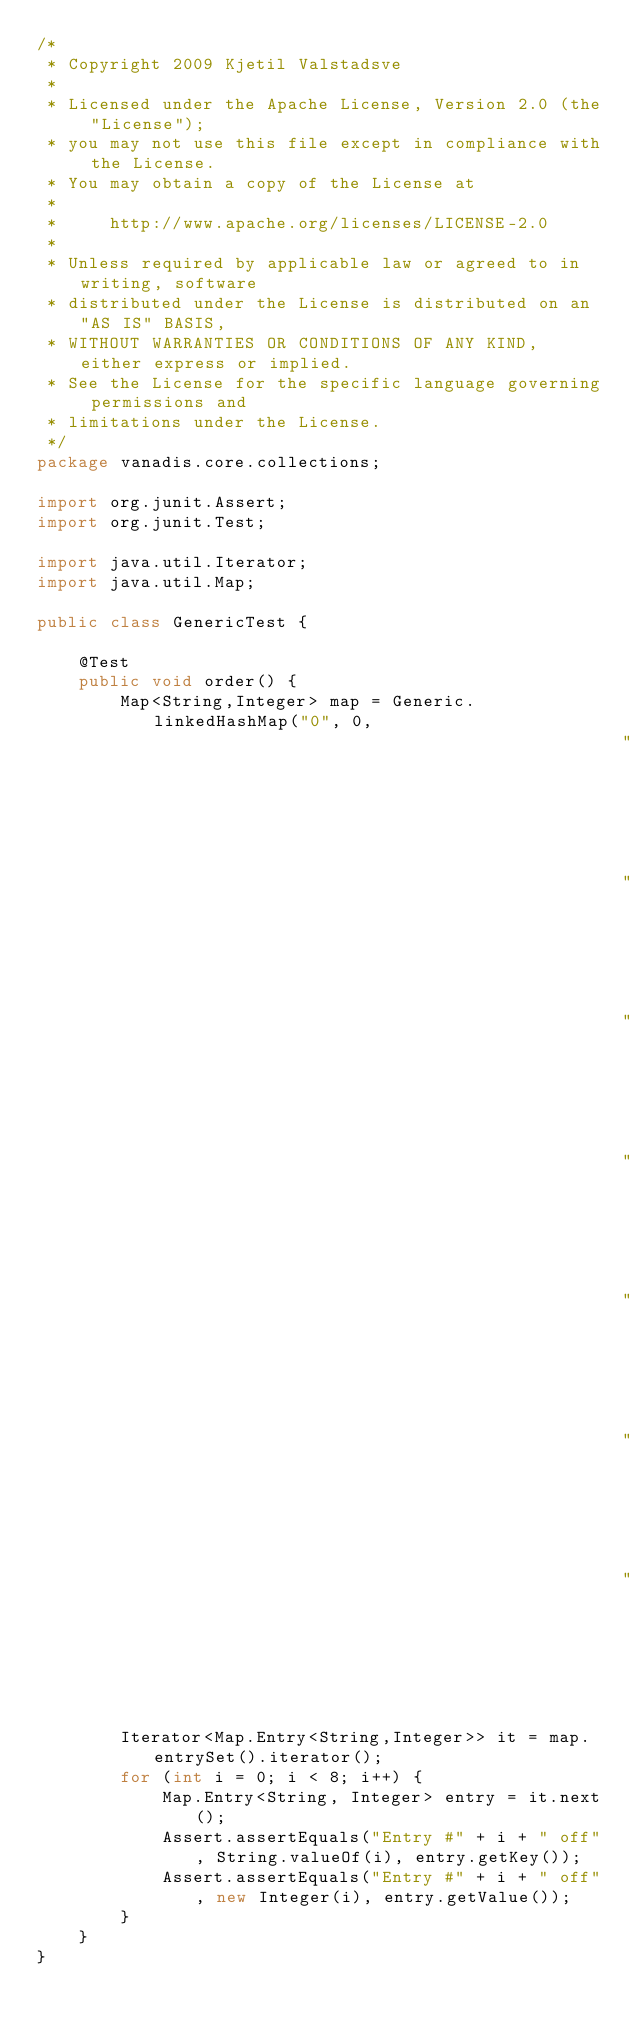Convert code to text. <code><loc_0><loc_0><loc_500><loc_500><_Java_>/*
 * Copyright 2009 Kjetil Valstadsve
 *
 * Licensed under the Apache License, Version 2.0 (the "License");
 * you may not use this file except in compliance with the License.
 * You may obtain a copy of the License at
 *
 *     http://www.apache.org/licenses/LICENSE-2.0
 *
 * Unless required by applicable law or agreed to in writing, software
 * distributed under the License is distributed on an "AS IS" BASIS,
 * WITHOUT WARRANTIES OR CONDITIONS OF ANY KIND, either express or implied.
 * See the License for the specific language governing permissions and
 * limitations under the License.
 */
package vanadis.core.collections;

import org.junit.Assert;
import org.junit.Test;

import java.util.Iterator;
import java.util.Map;

public class GenericTest {

    @Test
    public void order() {
        Map<String,Integer> map = Generic.linkedHashMap("0", 0,
                                                        "1", 1,
                                                        "2", 2,
                                                        "3", 3,
                                                        "4", 4,
                                                        "5", 5,
                                                        "6", 6,
                                                        "7", 7);
        Iterator<Map.Entry<String,Integer>> it = map.entrySet().iterator();
        for (int i = 0; i < 8; i++) {
            Map.Entry<String, Integer> entry = it.next();
            Assert.assertEquals("Entry #" + i + " off", String.valueOf(i), entry.getKey());
            Assert.assertEquals("Entry #" + i + " off", new Integer(i), entry.getValue());
        }
    }
}
</code> 